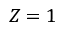Convert formula to latex. <formula><loc_0><loc_0><loc_500><loc_500>Z = 1</formula> 